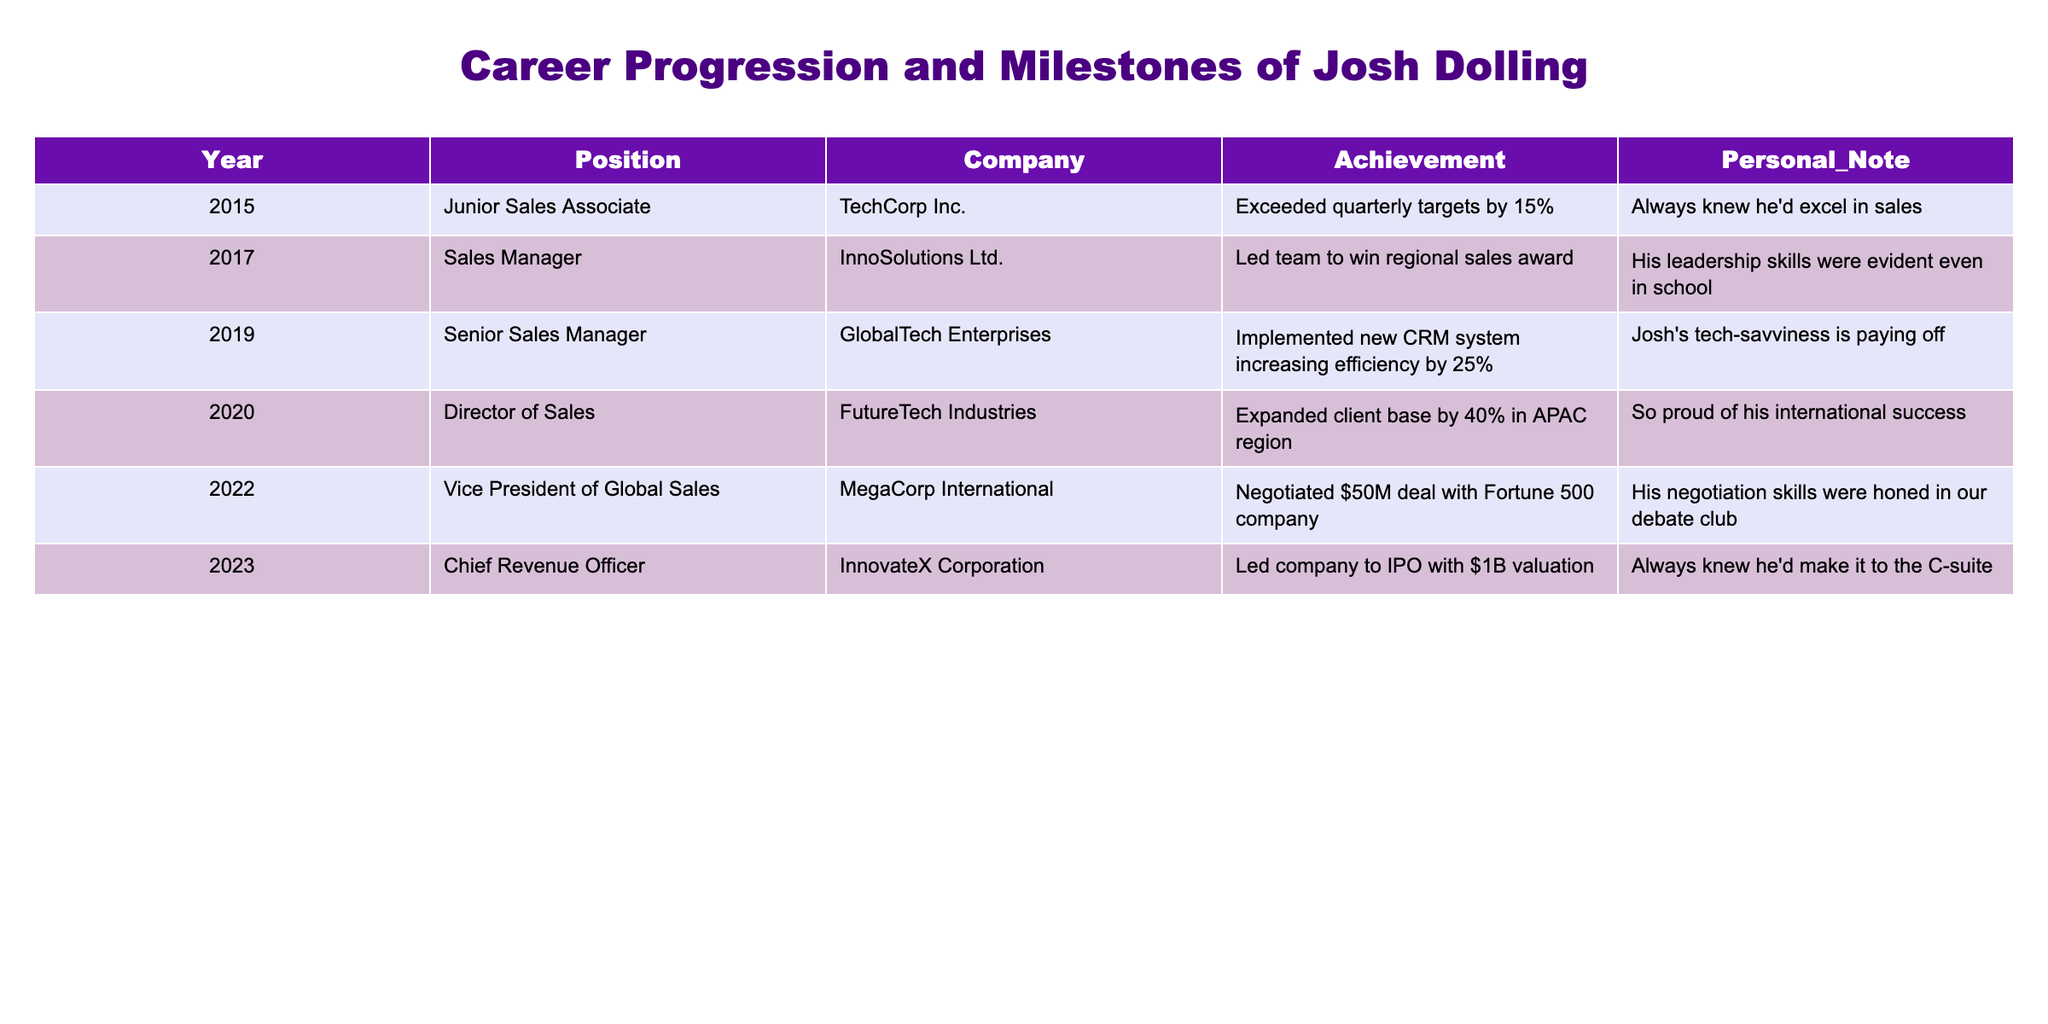What's the highest position Josh Dolling reached in his career? The highest position listed in the table is "Chief Revenue Officer" at InnovateX Corporation in 2023.
Answer: Chief Revenue Officer In which year did Josh Dolling become Vice President of Global Sales? According to the table, he assumed the position of Vice President of Global Sales in 2022.
Answer: 2022 How many years did it take Josh to progress from Junior Sales Associate to Director of Sales? Josh started as a Junior Sales Associate in 2015 and became Director of Sales in 2020. This is a difference of 5 years (2020 - 2015).
Answer: 5 years Which company did Josh achieve the negotiation of a $50M deal with? The table states that the deal was negotiated at MegaCorp International when he was Vice President of Global Sales.
Answer: MegaCorp International Did Josh achieve any notable awards during his career progression? Yes, he led his team to win a regional sales award in 2017 while at InnoSolutions Ltd.
Answer: Yes Which achievement indicates an increase in efficiency and in what position did he accomplish it? Josh implemented a new CRM system increasing efficiency by 25% while he was Senior Sales Manager at GlobalTech Enterprises in 2019.
Answer: Senior Sales Manager What percentage did Josh expand the client base by in the APAC region? He expanded the client base by 40% in the APAC region while working as Director of Sales at FutureTech Industries.
Answer: 40% Between which two positions did Josh experience the most rapid career growth based on the years? Josh went from Sales Manager in 2017 to Senior Sales Manager in 2019, marking a 2-year span for promotion, the quickest growth phase.
Answer: Sales Manager to Senior Sales Manager Which role did Josh have when he first started to focus on international markets? Josh focused on international markets when he became Director of Sales at FutureTech Industries in 2020.
Answer: Director of Sales How many total positions has Josh Dolling held according to the table? The table records a total of 6 positions held by Josh, from Junior Sales Associate to Chief Revenue Officer.
Answer: 6 positions 